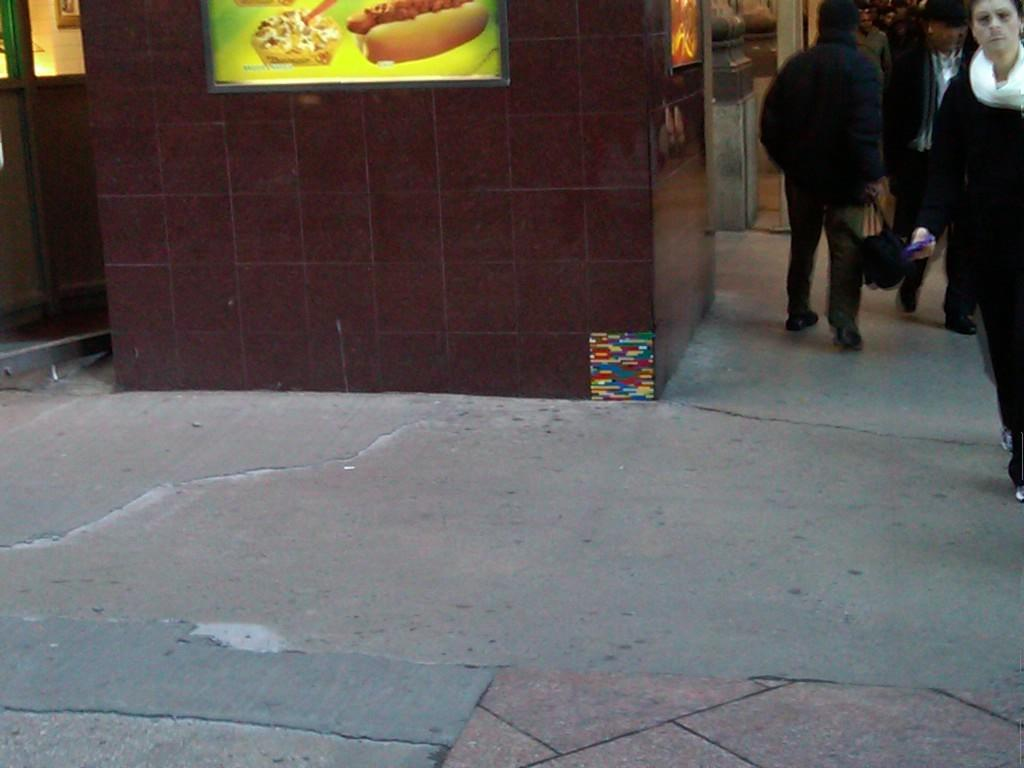What is happening in the image? There is a group of people standing in the image. Can you describe the surroundings in the image? There are frames attached to the walls in the image. What type of volleyball game is being played in the image? There is no volleyball game present in the image; it only shows a group of people standing and frames on the walls. How many ducks are visible in the image? There are no ducks present in the image. 